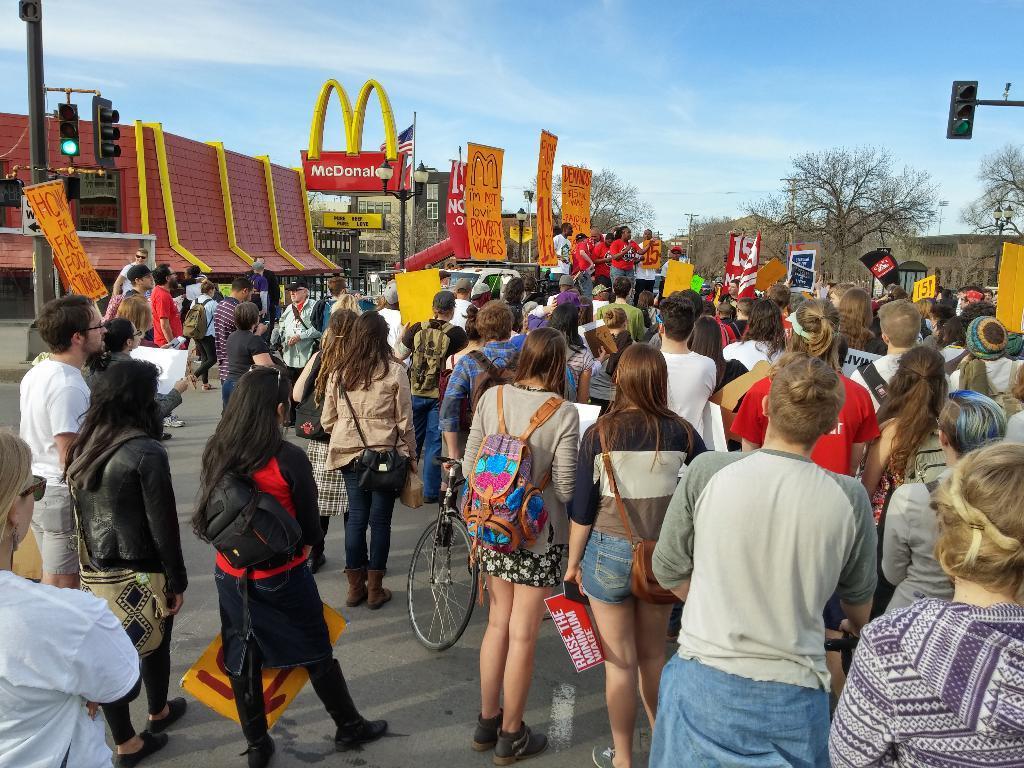Can you describe this image briefly? There is a crowd. Some are wearing bags and holding some placards. In the back there are banners, buildings, traffic lights with poles, trees and sky. 